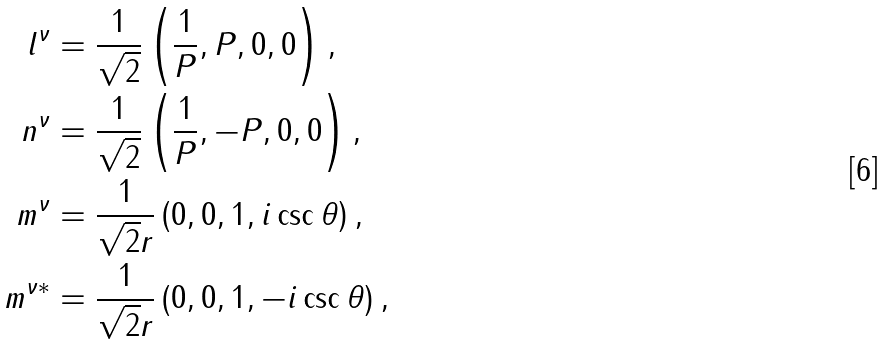<formula> <loc_0><loc_0><loc_500><loc_500>l ^ { \nu } & = \frac { 1 } { \sqrt { 2 } } \left ( \frac { 1 } { P } , P , 0 , 0 \right ) , \\ n ^ { \nu } & = \frac { 1 } { \sqrt { 2 } } \left ( \frac { 1 } { P } , - P , 0 , 0 \right ) , \\ m ^ { \nu } & = \frac { 1 } { \sqrt { 2 } r } \left ( 0 , 0 , 1 , i \csc \theta \right ) , \\ m ^ { \nu * } & = \frac { 1 } { \sqrt { 2 } r } \left ( 0 , 0 , 1 , - i \csc \theta \right ) ,</formula> 